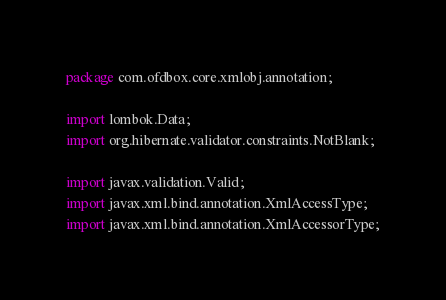<code> <loc_0><loc_0><loc_500><loc_500><_Java_>package com.ofdbox.core.xmlobj.annotation;

import lombok.Data;
import org.hibernate.validator.constraints.NotBlank;

import javax.validation.Valid;
import javax.xml.bind.annotation.XmlAccessType;
import javax.xml.bind.annotation.XmlAccessorType;</code> 